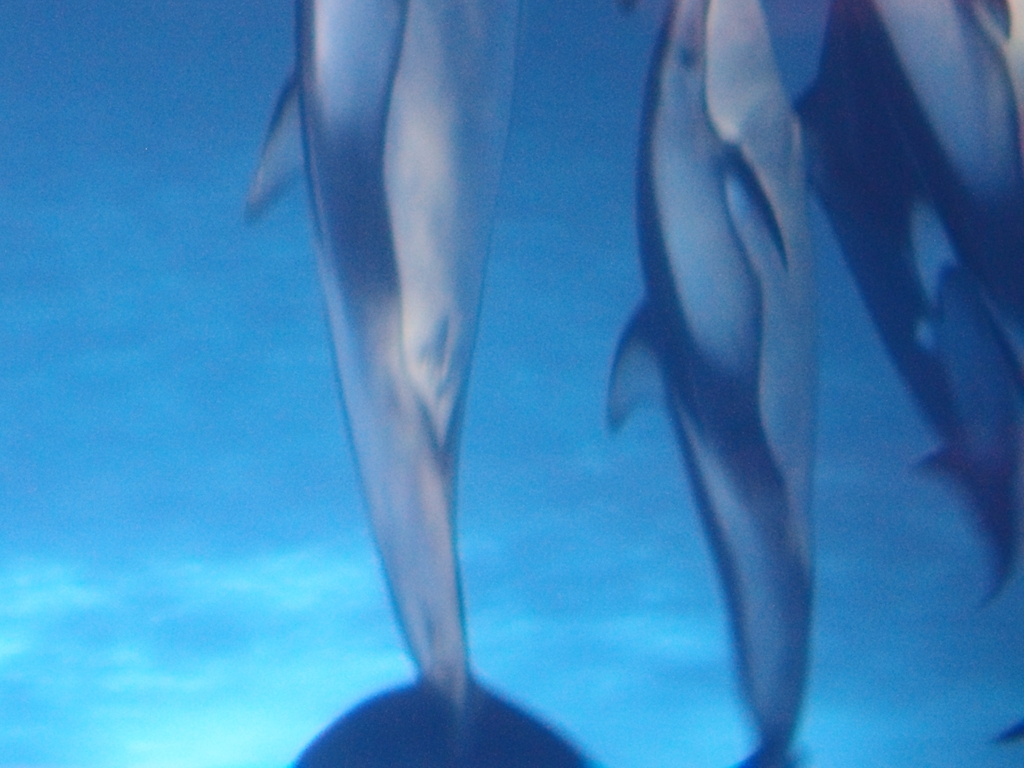What is unique about this underwater view of the dolphins? The underwater perspective offers a unique vantage point to observe the dolphins in their natural habitat. It provides insight into their fluid movement and social interactions, which are less discernible from above the water's surface. How does the blur effect the perception of movement in the image? The blur creates a sense of motion, conveying the swift and graceful movement of the dolphins. While it detracts from the clarity of the subjects, it adds a dynamic quality to the image that suggests their speed and agility. 